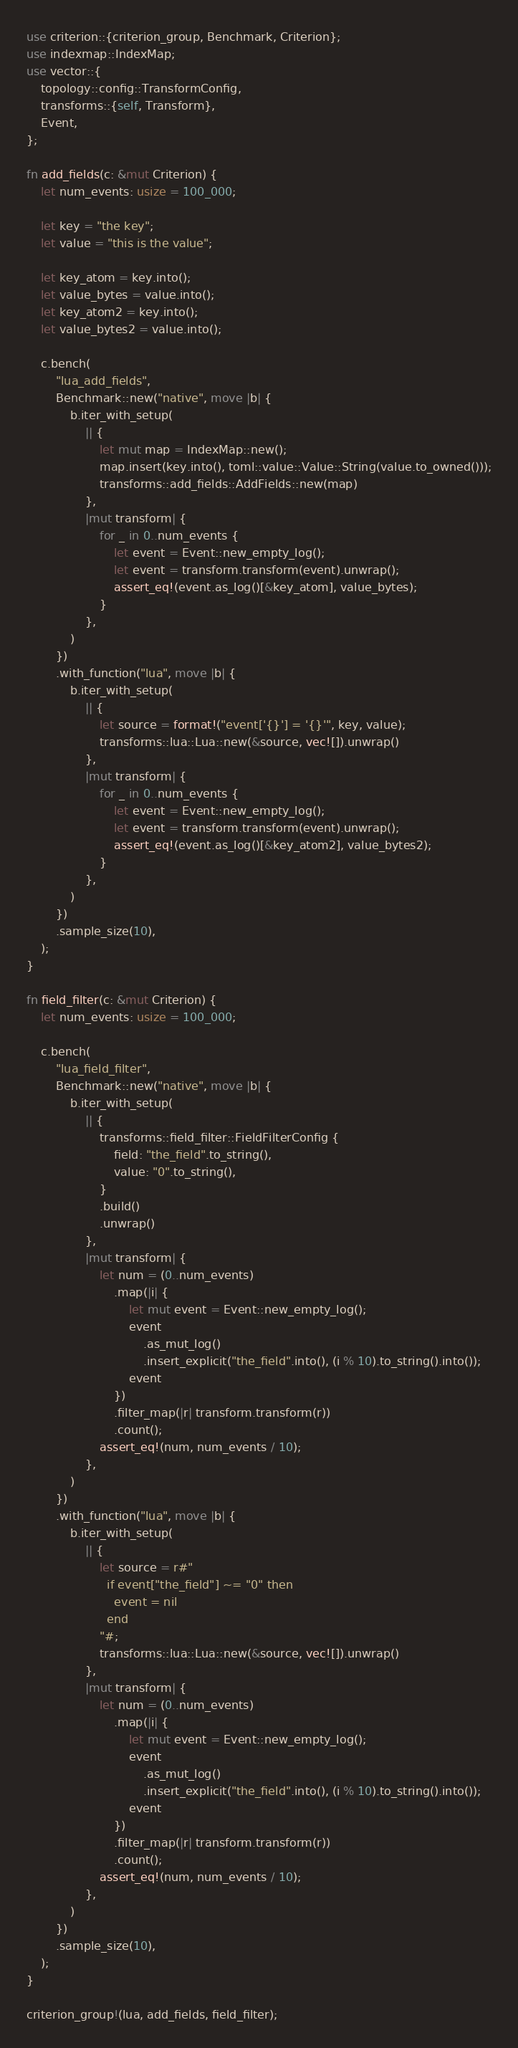<code> <loc_0><loc_0><loc_500><loc_500><_Rust_>use criterion::{criterion_group, Benchmark, Criterion};
use indexmap::IndexMap;
use vector::{
    topology::config::TransformConfig,
    transforms::{self, Transform},
    Event,
};

fn add_fields(c: &mut Criterion) {
    let num_events: usize = 100_000;

    let key = "the key";
    let value = "this is the value";

    let key_atom = key.into();
    let value_bytes = value.into();
    let key_atom2 = key.into();
    let value_bytes2 = value.into();

    c.bench(
        "lua_add_fields",
        Benchmark::new("native", move |b| {
            b.iter_with_setup(
                || {
                    let mut map = IndexMap::new();
                    map.insert(key.into(), toml::value::Value::String(value.to_owned()));
                    transforms::add_fields::AddFields::new(map)
                },
                |mut transform| {
                    for _ in 0..num_events {
                        let event = Event::new_empty_log();
                        let event = transform.transform(event).unwrap();
                        assert_eq!(event.as_log()[&key_atom], value_bytes);
                    }
                },
            )
        })
        .with_function("lua", move |b| {
            b.iter_with_setup(
                || {
                    let source = format!("event['{}'] = '{}'", key, value);
                    transforms::lua::Lua::new(&source, vec![]).unwrap()
                },
                |mut transform| {
                    for _ in 0..num_events {
                        let event = Event::new_empty_log();
                        let event = transform.transform(event).unwrap();
                        assert_eq!(event.as_log()[&key_atom2], value_bytes2);
                    }
                },
            )
        })
        .sample_size(10),
    );
}

fn field_filter(c: &mut Criterion) {
    let num_events: usize = 100_000;

    c.bench(
        "lua_field_filter",
        Benchmark::new("native", move |b| {
            b.iter_with_setup(
                || {
                    transforms::field_filter::FieldFilterConfig {
                        field: "the_field".to_string(),
                        value: "0".to_string(),
                    }
                    .build()
                    .unwrap()
                },
                |mut transform| {
                    let num = (0..num_events)
                        .map(|i| {
                            let mut event = Event::new_empty_log();
                            event
                                .as_mut_log()
                                .insert_explicit("the_field".into(), (i % 10).to_string().into());
                            event
                        })
                        .filter_map(|r| transform.transform(r))
                        .count();
                    assert_eq!(num, num_events / 10);
                },
            )
        })
        .with_function("lua", move |b| {
            b.iter_with_setup(
                || {
                    let source = r#"
                      if event["the_field"] ~= "0" then
                        event = nil
                      end
                    "#;
                    transforms::lua::Lua::new(&source, vec![]).unwrap()
                },
                |mut transform| {
                    let num = (0..num_events)
                        .map(|i| {
                            let mut event = Event::new_empty_log();
                            event
                                .as_mut_log()
                                .insert_explicit("the_field".into(), (i % 10).to_string().into());
                            event
                        })
                        .filter_map(|r| transform.transform(r))
                        .count();
                    assert_eq!(num, num_events / 10);
                },
            )
        })
        .sample_size(10),
    );
}

criterion_group!(lua, add_fields, field_filter);
</code> 